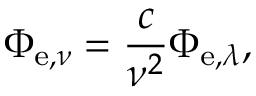Convert formula to latex. <formula><loc_0><loc_0><loc_500><loc_500>\Phi _ { e , \nu } = { \frac { c } { \nu ^ { 2 } } } \Phi _ { e , \lambda } ,</formula> 